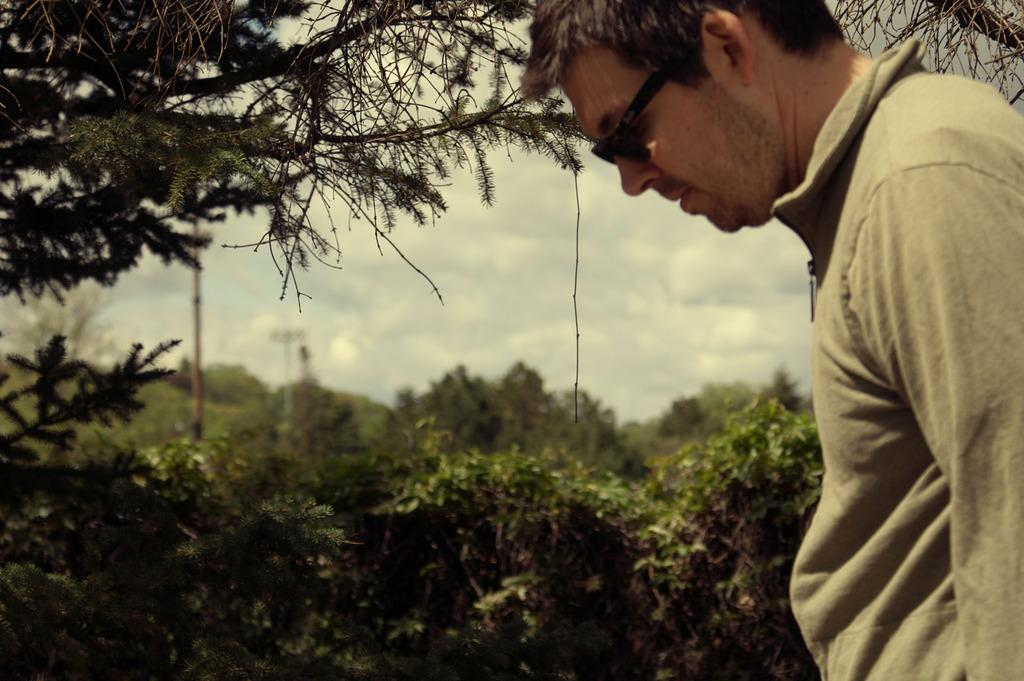Who or what is present in the image? There is a person in the image. What type of natural environment can be seen in the image? There are trees in the image, which may suggest a forest setting. What artificial structures are visible in the image? There are light poles in the image. What is visible in the background of the image? The sky is visible in the image. What type of disgust can be seen on the person's face in the image? There is no indication of disgust on the person's face in the image. What type of request is the person making in the image? There is no indication of a request being made in the image. 